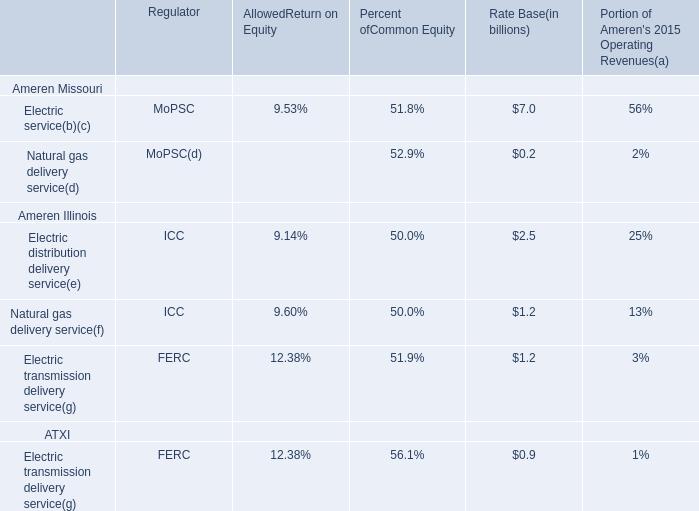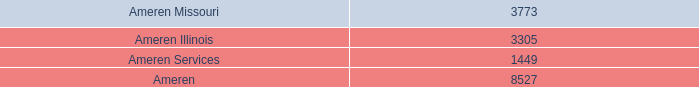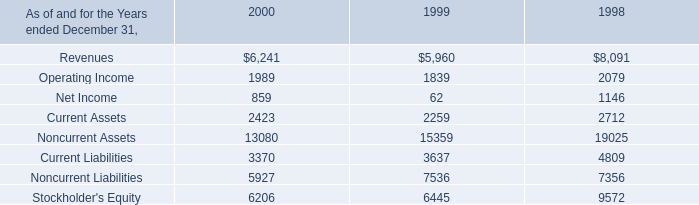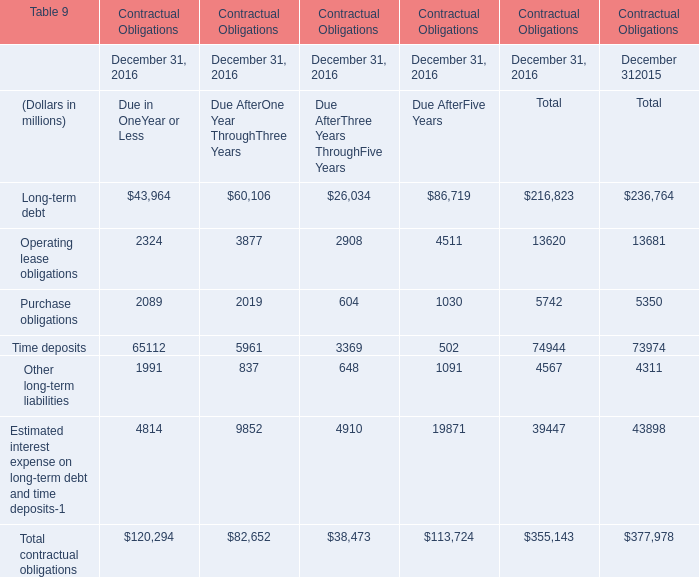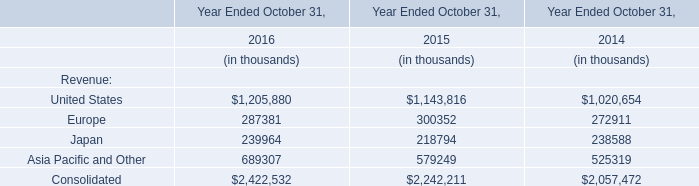What's the total amount of Operating lease obligations and Purchase obligations in 2016? (in millions) 
Computations: (13620 + 5742)
Answer: 19362.0. 